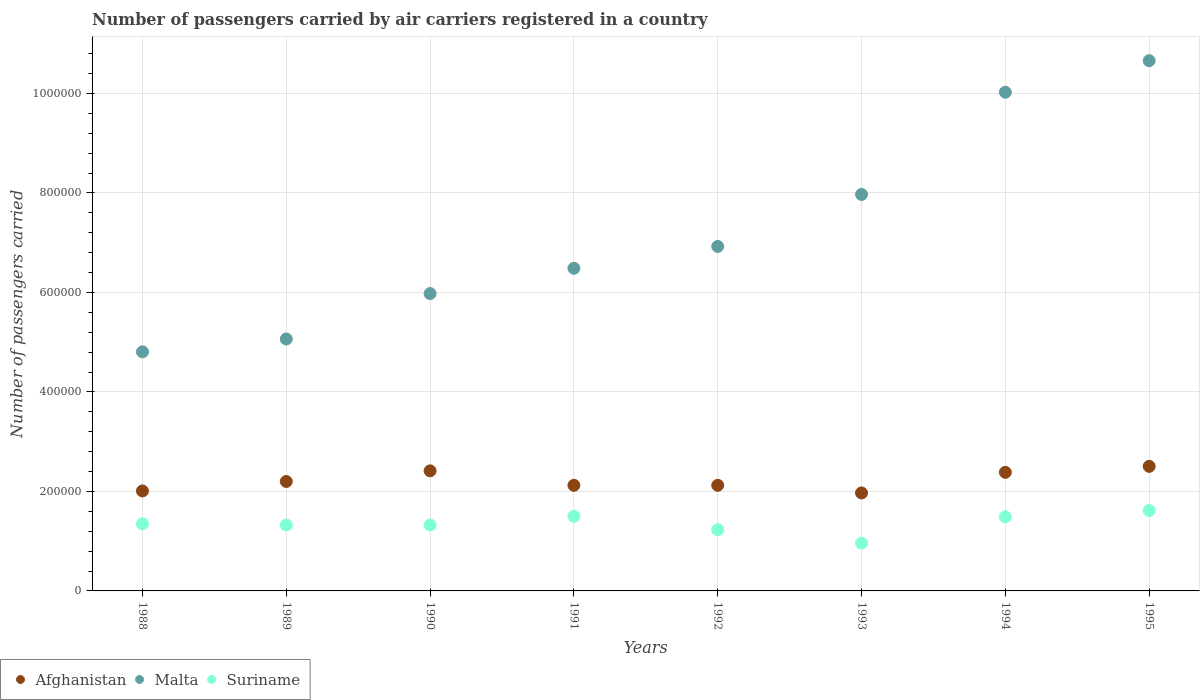Is the number of dotlines equal to the number of legend labels?
Offer a very short reply. Yes. What is the number of passengers carried by air carriers in Malta in 1991?
Ensure brevity in your answer.  6.49e+05. Across all years, what is the maximum number of passengers carried by air carriers in Afghanistan?
Give a very brief answer. 2.50e+05. Across all years, what is the minimum number of passengers carried by air carriers in Suriname?
Provide a succinct answer. 9.60e+04. In which year was the number of passengers carried by air carriers in Afghanistan minimum?
Keep it short and to the point. 1993. What is the total number of passengers carried by air carriers in Malta in the graph?
Your response must be concise. 5.79e+06. What is the difference between the number of passengers carried by air carriers in Afghanistan in 1988 and that in 1995?
Your answer should be very brief. -4.94e+04. What is the difference between the number of passengers carried by air carriers in Suriname in 1993 and the number of passengers carried by air carriers in Malta in 1992?
Keep it short and to the point. -5.96e+05. What is the average number of passengers carried by air carriers in Suriname per year?
Give a very brief answer. 1.35e+05. In the year 1988, what is the difference between the number of passengers carried by air carriers in Afghanistan and number of passengers carried by air carriers in Suriname?
Your answer should be compact. 6.60e+04. In how many years, is the number of passengers carried by air carriers in Malta greater than 240000?
Offer a terse response. 8. What is the ratio of the number of passengers carried by air carriers in Malta in 1993 to that in 1994?
Keep it short and to the point. 0.8. Is the number of passengers carried by air carriers in Afghanistan in 1990 less than that in 1993?
Make the answer very short. No. What is the difference between the highest and the second highest number of passengers carried by air carriers in Suriname?
Offer a terse response. 1.18e+04. What is the difference between the highest and the lowest number of passengers carried by air carriers in Malta?
Offer a very short reply. 5.85e+05. In how many years, is the number of passengers carried by air carriers in Suriname greater than the average number of passengers carried by air carriers in Suriname taken over all years?
Your answer should be compact. 4. Is it the case that in every year, the sum of the number of passengers carried by air carriers in Suriname and number of passengers carried by air carriers in Afghanistan  is greater than the number of passengers carried by air carriers in Malta?
Provide a succinct answer. No. Is the number of passengers carried by air carriers in Suriname strictly greater than the number of passengers carried by air carriers in Malta over the years?
Your response must be concise. No. Is the number of passengers carried by air carriers in Suriname strictly less than the number of passengers carried by air carriers in Malta over the years?
Provide a succinct answer. Yes. How many dotlines are there?
Provide a succinct answer. 3. Are the values on the major ticks of Y-axis written in scientific E-notation?
Give a very brief answer. No. Does the graph contain any zero values?
Your response must be concise. No. Where does the legend appear in the graph?
Ensure brevity in your answer.  Bottom left. How many legend labels are there?
Your answer should be compact. 3. How are the legend labels stacked?
Your answer should be compact. Horizontal. What is the title of the graph?
Provide a short and direct response. Number of passengers carried by air carriers registered in a country. Does "Grenada" appear as one of the legend labels in the graph?
Offer a terse response. No. What is the label or title of the X-axis?
Offer a very short reply. Years. What is the label or title of the Y-axis?
Ensure brevity in your answer.  Number of passengers carried. What is the Number of passengers carried of Afghanistan in 1988?
Your answer should be very brief. 2.01e+05. What is the Number of passengers carried in Malta in 1988?
Give a very brief answer. 4.81e+05. What is the Number of passengers carried in Suriname in 1988?
Your answer should be compact. 1.35e+05. What is the Number of passengers carried in Malta in 1989?
Your answer should be compact. 5.06e+05. What is the Number of passengers carried in Suriname in 1989?
Provide a succinct answer. 1.32e+05. What is the Number of passengers carried in Afghanistan in 1990?
Your answer should be compact. 2.41e+05. What is the Number of passengers carried in Malta in 1990?
Give a very brief answer. 5.98e+05. What is the Number of passengers carried in Suriname in 1990?
Offer a terse response. 1.32e+05. What is the Number of passengers carried in Afghanistan in 1991?
Your response must be concise. 2.12e+05. What is the Number of passengers carried in Malta in 1991?
Keep it short and to the point. 6.49e+05. What is the Number of passengers carried of Afghanistan in 1992?
Your response must be concise. 2.12e+05. What is the Number of passengers carried in Malta in 1992?
Offer a terse response. 6.92e+05. What is the Number of passengers carried in Suriname in 1992?
Provide a short and direct response. 1.23e+05. What is the Number of passengers carried in Afghanistan in 1993?
Offer a terse response. 1.97e+05. What is the Number of passengers carried of Malta in 1993?
Offer a terse response. 7.97e+05. What is the Number of passengers carried in Suriname in 1993?
Your answer should be compact. 9.60e+04. What is the Number of passengers carried in Afghanistan in 1994?
Give a very brief answer. 2.38e+05. What is the Number of passengers carried of Malta in 1994?
Make the answer very short. 1.00e+06. What is the Number of passengers carried of Suriname in 1994?
Make the answer very short. 1.49e+05. What is the Number of passengers carried of Afghanistan in 1995?
Your response must be concise. 2.50e+05. What is the Number of passengers carried in Malta in 1995?
Provide a succinct answer. 1.07e+06. What is the Number of passengers carried in Suriname in 1995?
Ensure brevity in your answer.  1.62e+05. Across all years, what is the maximum Number of passengers carried of Afghanistan?
Your answer should be very brief. 2.50e+05. Across all years, what is the maximum Number of passengers carried of Malta?
Provide a short and direct response. 1.07e+06. Across all years, what is the maximum Number of passengers carried of Suriname?
Make the answer very short. 1.62e+05. Across all years, what is the minimum Number of passengers carried of Afghanistan?
Give a very brief answer. 1.97e+05. Across all years, what is the minimum Number of passengers carried in Malta?
Ensure brevity in your answer.  4.81e+05. Across all years, what is the minimum Number of passengers carried in Suriname?
Ensure brevity in your answer.  9.60e+04. What is the total Number of passengers carried in Afghanistan in the graph?
Provide a succinct answer. 1.77e+06. What is the total Number of passengers carried in Malta in the graph?
Give a very brief answer. 5.79e+06. What is the total Number of passengers carried in Suriname in the graph?
Provide a succinct answer. 1.08e+06. What is the difference between the Number of passengers carried of Afghanistan in 1988 and that in 1989?
Offer a very short reply. -1.90e+04. What is the difference between the Number of passengers carried of Malta in 1988 and that in 1989?
Provide a succinct answer. -2.59e+04. What is the difference between the Number of passengers carried in Suriname in 1988 and that in 1989?
Your response must be concise. 2500. What is the difference between the Number of passengers carried of Afghanistan in 1988 and that in 1990?
Your answer should be very brief. -4.04e+04. What is the difference between the Number of passengers carried of Malta in 1988 and that in 1990?
Your response must be concise. -1.17e+05. What is the difference between the Number of passengers carried of Suriname in 1988 and that in 1990?
Your response must be concise. 2500. What is the difference between the Number of passengers carried in Afghanistan in 1988 and that in 1991?
Offer a terse response. -1.13e+04. What is the difference between the Number of passengers carried of Malta in 1988 and that in 1991?
Provide a succinct answer. -1.68e+05. What is the difference between the Number of passengers carried of Suriname in 1988 and that in 1991?
Your response must be concise. -1.50e+04. What is the difference between the Number of passengers carried of Afghanistan in 1988 and that in 1992?
Make the answer very short. -1.13e+04. What is the difference between the Number of passengers carried in Malta in 1988 and that in 1992?
Provide a short and direct response. -2.12e+05. What is the difference between the Number of passengers carried of Suriname in 1988 and that in 1992?
Make the answer very short. 1.20e+04. What is the difference between the Number of passengers carried in Afghanistan in 1988 and that in 1993?
Your answer should be very brief. 4000. What is the difference between the Number of passengers carried in Malta in 1988 and that in 1993?
Offer a very short reply. -3.16e+05. What is the difference between the Number of passengers carried in Suriname in 1988 and that in 1993?
Give a very brief answer. 3.90e+04. What is the difference between the Number of passengers carried of Afghanistan in 1988 and that in 1994?
Give a very brief answer. -3.74e+04. What is the difference between the Number of passengers carried in Malta in 1988 and that in 1994?
Provide a succinct answer. -5.22e+05. What is the difference between the Number of passengers carried in Suriname in 1988 and that in 1994?
Ensure brevity in your answer.  -1.39e+04. What is the difference between the Number of passengers carried in Afghanistan in 1988 and that in 1995?
Your response must be concise. -4.94e+04. What is the difference between the Number of passengers carried of Malta in 1988 and that in 1995?
Offer a terse response. -5.85e+05. What is the difference between the Number of passengers carried in Suriname in 1988 and that in 1995?
Provide a short and direct response. -2.68e+04. What is the difference between the Number of passengers carried of Afghanistan in 1989 and that in 1990?
Keep it short and to the point. -2.14e+04. What is the difference between the Number of passengers carried in Malta in 1989 and that in 1990?
Provide a succinct answer. -9.13e+04. What is the difference between the Number of passengers carried in Suriname in 1989 and that in 1990?
Keep it short and to the point. 0. What is the difference between the Number of passengers carried in Afghanistan in 1989 and that in 1991?
Your answer should be compact. 7700. What is the difference between the Number of passengers carried of Malta in 1989 and that in 1991?
Make the answer very short. -1.42e+05. What is the difference between the Number of passengers carried in Suriname in 1989 and that in 1991?
Provide a short and direct response. -1.75e+04. What is the difference between the Number of passengers carried in Afghanistan in 1989 and that in 1992?
Your response must be concise. 7700. What is the difference between the Number of passengers carried of Malta in 1989 and that in 1992?
Make the answer very short. -1.86e+05. What is the difference between the Number of passengers carried of Suriname in 1989 and that in 1992?
Offer a terse response. 9500. What is the difference between the Number of passengers carried of Afghanistan in 1989 and that in 1993?
Your response must be concise. 2.30e+04. What is the difference between the Number of passengers carried of Malta in 1989 and that in 1993?
Offer a terse response. -2.90e+05. What is the difference between the Number of passengers carried of Suriname in 1989 and that in 1993?
Provide a short and direct response. 3.65e+04. What is the difference between the Number of passengers carried of Afghanistan in 1989 and that in 1994?
Provide a short and direct response. -1.84e+04. What is the difference between the Number of passengers carried in Malta in 1989 and that in 1994?
Keep it short and to the point. -4.96e+05. What is the difference between the Number of passengers carried in Suriname in 1989 and that in 1994?
Provide a short and direct response. -1.64e+04. What is the difference between the Number of passengers carried of Afghanistan in 1989 and that in 1995?
Your answer should be compact. -3.04e+04. What is the difference between the Number of passengers carried of Malta in 1989 and that in 1995?
Ensure brevity in your answer.  -5.59e+05. What is the difference between the Number of passengers carried in Suriname in 1989 and that in 1995?
Offer a terse response. -2.93e+04. What is the difference between the Number of passengers carried of Afghanistan in 1990 and that in 1991?
Give a very brief answer. 2.91e+04. What is the difference between the Number of passengers carried of Malta in 1990 and that in 1991?
Your answer should be very brief. -5.08e+04. What is the difference between the Number of passengers carried of Suriname in 1990 and that in 1991?
Offer a very short reply. -1.75e+04. What is the difference between the Number of passengers carried in Afghanistan in 1990 and that in 1992?
Your answer should be very brief. 2.91e+04. What is the difference between the Number of passengers carried in Malta in 1990 and that in 1992?
Ensure brevity in your answer.  -9.47e+04. What is the difference between the Number of passengers carried of Suriname in 1990 and that in 1992?
Provide a succinct answer. 9500. What is the difference between the Number of passengers carried of Afghanistan in 1990 and that in 1993?
Your answer should be very brief. 4.44e+04. What is the difference between the Number of passengers carried in Malta in 1990 and that in 1993?
Offer a terse response. -1.99e+05. What is the difference between the Number of passengers carried in Suriname in 1990 and that in 1993?
Your answer should be compact. 3.65e+04. What is the difference between the Number of passengers carried of Afghanistan in 1990 and that in 1994?
Provide a succinct answer. 3000. What is the difference between the Number of passengers carried of Malta in 1990 and that in 1994?
Give a very brief answer. -4.05e+05. What is the difference between the Number of passengers carried in Suriname in 1990 and that in 1994?
Ensure brevity in your answer.  -1.64e+04. What is the difference between the Number of passengers carried in Afghanistan in 1990 and that in 1995?
Provide a succinct answer. -9000. What is the difference between the Number of passengers carried in Malta in 1990 and that in 1995?
Offer a very short reply. -4.68e+05. What is the difference between the Number of passengers carried of Suriname in 1990 and that in 1995?
Provide a succinct answer. -2.93e+04. What is the difference between the Number of passengers carried of Afghanistan in 1991 and that in 1992?
Ensure brevity in your answer.  0. What is the difference between the Number of passengers carried in Malta in 1991 and that in 1992?
Provide a short and direct response. -4.39e+04. What is the difference between the Number of passengers carried in Suriname in 1991 and that in 1992?
Provide a succinct answer. 2.70e+04. What is the difference between the Number of passengers carried of Afghanistan in 1991 and that in 1993?
Offer a terse response. 1.53e+04. What is the difference between the Number of passengers carried of Malta in 1991 and that in 1993?
Give a very brief answer. -1.48e+05. What is the difference between the Number of passengers carried in Suriname in 1991 and that in 1993?
Your answer should be very brief. 5.40e+04. What is the difference between the Number of passengers carried in Afghanistan in 1991 and that in 1994?
Provide a succinct answer. -2.61e+04. What is the difference between the Number of passengers carried of Malta in 1991 and that in 1994?
Keep it short and to the point. -3.54e+05. What is the difference between the Number of passengers carried of Suriname in 1991 and that in 1994?
Your answer should be very brief. 1100. What is the difference between the Number of passengers carried of Afghanistan in 1991 and that in 1995?
Keep it short and to the point. -3.81e+04. What is the difference between the Number of passengers carried in Malta in 1991 and that in 1995?
Provide a short and direct response. -4.17e+05. What is the difference between the Number of passengers carried of Suriname in 1991 and that in 1995?
Keep it short and to the point. -1.18e+04. What is the difference between the Number of passengers carried of Afghanistan in 1992 and that in 1993?
Keep it short and to the point. 1.53e+04. What is the difference between the Number of passengers carried of Malta in 1992 and that in 1993?
Offer a very short reply. -1.04e+05. What is the difference between the Number of passengers carried of Suriname in 1992 and that in 1993?
Your answer should be very brief. 2.70e+04. What is the difference between the Number of passengers carried of Afghanistan in 1992 and that in 1994?
Your response must be concise. -2.61e+04. What is the difference between the Number of passengers carried of Malta in 1992 and that in 1994?
Make the answer very short. -3.10e+05. What is the difference between the Number of passengers carried of Suriname in 1992 and that in 1994?
Keep it short and to the point. -2.59e+04. What is the difference between the Number of passengers carried of Afghanistan in 1992 and that in 1995?
Provide a succinct answer. -3.81e+04. What is the difference between the Number of passengers carried in Malta in 1992 and that in 1995?
Provide a short and direct response. -3.73e+05. What is the difference between the Number of passengers carried of Suriname in 1992 and that in 1995?
Make the answer very short. -3.88e+04. What is the difference between the Number of passengers carried of Afghanistan in 1993 and that in 1994?
Your answer should be compact. -4.14e+04. What is the difference between the Number of passengers carried of Malta in 1993 and that in 1994?
Your response must be concise. -2.06e+05. What is the difference between the Number of passengers carried in Suriname in 1993 and that in 1994?
Offer a terse response. -5.29e+04. What is the difference between the Number of passengers carried of Afghanistan in 1993 and that in 1995?
Provide a short and direct response. -5.34e+04. What is the difference between the Number of passengers carried in Malta in 1993 and that in 1995?
Your response must be concise. -2.69e+05. What is the difference between the Number of passengers carried of Suriname in 1993 and that in 1995?
Give a very brief answer. -6.58e+04. What is the difference between the Number of passengers carried in Afghanistan in 1994 and that in 1995?
Offer a very short reply. -1.20e+04. What is the difference between the Number of passengers carried of Malta in 1994 and that in 1995?
Provide a short and direct response. -6.34e+04. What is the difference between the Number of passengers carried of Suriname in 1994 and that in 1995?
Keep it short and to the point. -1.29e+04. What is the difference between the Number of passengers carried of Afghanistan in 1988 and the Number of passengers carried of Malta in 1989?
Give a very brief answer. -3.06e+05. What is the difference between the Number of passengers carried in Afghanistan in 1988 and the Number of passengers carried in Suriname in 1989?
Give a very brief answer. 6.85e+04. What is the difference between the Number of passengers carried in Malta in 1988 and the Number of passengers carried in Suriname in 1989?
Offer a very short reply. 3.48e+05. What is the difference between the Number of passengers carried of Afghanistan in 1988 and the Number of passengers carried of Malta in 1990?
Your answer should be very brief. -3.97e+05. What is the difference between the Number of passengers carried in Afghanistan in 1988 and the Number of passengers carried in Suriname in 1990?
Give a very brief answer. 6.85e+04. What is the difference between the Number of passengers carried of Malta in 1988 and the Number of passengers carried of Suriname in 1990?
Ensure brevity in your answer.  3.48e+05. What is the difference between the Number of passengers carried in Afghanistan in 1988 and the Number of passengers carried in Malta in 1991?
Make the answer very short. -4.48e+05. What is the difference between the Number of passengers carried in Afghanistan in 1988 and the Number of passengers carried in Suriname in 1991?
Offer a very short reply. 5.10e+04. What is the difference between the Number of passengers carried of Malta in 1988 and the Number of passengers carried of Suriname in 1991?
Provide a succinct answer. 3.31e+05. What is the difference between the Number of passengers carried in Afghanistan in 1988 and the Number of passengers carried in Malta in 1992?
Keep it short and to the point. -4.92e+05. What is the difference between the Number of passengers carried in Afghanistan in 1988 and the Number of passengers carried in Suriname in 1992?
Your answer should be compact. 7.80e+04. What is the difference between the Number of passengers carried in Malta in 1988 and the Number of passengers carried in Suriname in 1992?
Your answer should be compact. 3.58e+05. What is the difference between the Number of passengers carried in Afghanistan in 1988 and the Number of passengers carried in Malta in 1993?
Keep it short and to the point. -5.96e+05. What is the difference between the Number of passengers carried in Afghanistan in 1988 and the Number of passengers carried in Suriname in 1993?
Keep it short and to the point. 1.05e+05. What is the difference between the Number of passengers carried in Malta in 1988 and the Number of passengers carried in Suriname in 1993?
Provide a succinct answer. 3.85e+05. What is the difference between the Number of passengers carried of Afghanistan in 1988 and the Number of passengers carried of Malta in 1994?
Offer a terse response. -8.02e+05. What is the difference between the Number of passengers carried of Afghanistan in 1988 and the Number of passengers carried of Suriname in 1994?
Your answer should be very brief. 5.21e+04. What is the difference between the Number of passengers carried of Malta in 1988 and the Number of passengers carried of Suriname in 1994?
Offer a terse response. 3.32e+05. What is the difference between the Number of passengers carried of Afghanistan in 1988 and the Number of passengers carried of Malta in 1995?
Ensure brevity in your answer.  -8.65e+05. What is the difference between the Number of passengers carried in Afghanistan in 1988 and the Number of passengers carried in Suriname in 1995?
Keep it short and to the point. 3.92e+04. What is the difference between the Number of passengers carried in Malta in 1988 and the Number of passengers carried in Suriname in 1995?
Provide a short and direct response. 3.19e+05. What is the difference between the Number of passengers carried of Afghanistan in 1989 and the Number of passengers carried of Malta in 1990?
Provide a succinct answer. -3.78e+05. What is the difference between the Number of passengers carried in Afghanistan in 1989 and the Number of passengers carried in Suriname in 1990?
Ensure brevity in your answer.  8.75e+04. What is the difference between the Number of passengers carried of Malta in 1989 and the Number of passengers carried of Suriname in 1990?
Offer a terse response. 3.74e+05. What is the difference between the Number of passengers carried in Afghanistan in 1989 and the Number of passengers carried in Malta in 1991?
Provide a succinct answer. -4.29e+05. What is the difference between the Number of passengers carried of Afghanistan in 1989 and the Number of passengers carried of Suriname in 1991?
Your response must be concise. 7.00e+04. What is the difference between the Number of passengers carried of Malta in 1989 and the Number of passengers carried of Suriname in 1991?
Your answer should be very brief. 3.56e+05. What is the difference between the Number of passengers carried in Afghanistan in 1989 and the Number of passengers carried in Malta in 1992?
Give a very brief answer. -4.72e+05. What is the difference between the Number of passengers carried of Afghanistan in 1989 and the Number of passengers carried of Suriname in 1992?
Offer a terse response. 9.70e+04. What is the difference between the Number of passengers carried of Malta in 1989 and the Number of passengers carried of Suriname in 1992?
Keep it short and to the point. 3.84e+05. What is the difference between the Number of passengers carried of Afghanistan in 1989 and the Number of passengers carried of Malta in 1993?
Provide a short and direct response. -5.77e+05. What is the difference between the Number of passengers carried of Afghanistan in 1989 and the Number of passengers carried of Suriname in 1993?
Make the answer very short. 1.24e+05. What is the difference between the Number of passengers carried in Malta in 1989 and the Number of passengers carried in Suriname in 1993?
Offer a very short reply. 4.10e+05. What is the difference between the Number of passengers carried in Afghanistan in 1989 and the Number of passengers carried in Malta in 1994?
Ensure brevity in your answer.  -7.82e+05. What is the difference between the Number of passengers carried of Afghanistan in 1989 and the Number of passengers carried of Suriname in 1994?
Ensure brevity in your answer.  7.11e+04. What is the difference between the Number of passengers carried in Malta in 1989 and the Number of passengers carried in Suriname in 1994?
Offer a very short reply. 3.58e+05. What is the difference between the Number of passengers carried of Afghanistan in 1989 and the Number of passengers carried of Malta in 1995?
Your answer should be very brief. -8.46e+05. What is the difference between the Number of passengers carried of Afghanistan in 1989 and the Number of passengers carried of Suriname in 1995?
Make the answer very short. 5.82e+04. What is the difference between the Number of passengers carried in Malta in 1989 and the Number of passengers carried in Suriname in 1995?
Your response must be concise. 3.45e+05. What is the difference between the Number of passengers carried of Afghanistan in 1990 and the Number of passengers carried of Malta in 1991?
Your answer should be very brief. -4.07e+05. What is the difference between the Number of passengers carried of Afghanistan in 1990 and the Number of passengers carried of Suriname in 1991?
Give a very brief answer. 9.14e+04. What is the difference between the Number of passengers carried of Malta in 1990 and the Number of passengers carried of Suriname in 1991?
Your answer should be compact. 4.48e+05. What is the difference between the Number of passengers carried in Afghanistan in 1990 and the Number of passengers carried in Malta in 1992?
Offer a very short reply. -4.51e+05. What is the difference between the Number of passengers carried in Afghanistan in 1990 and the Number of passengers carried in Suriname in 1992?
Keep it short and to the point. 1.18e+05. What is the difference between the Number of passengers carried in Malta in 1990 and the Number of passengers carried in Suriname in 1992?
Make the answer very short. 4.75e+05. What is the difference between the Number of passengers carried in Afghanistan in 1990 and the Number of passengers carried in Malta in 1993?
Ensure brevity in your answer.  -5.56e+05. What is the difference between the Number of passengers carried of Afghanistan in 1990 and the Number of passengers carried of Suriname in 1993?
Make the answer very short. 1.45e+05. What is the difference between the Number of passengers carried of Malta in 1990 and the Number of passengers carried of Suriname in 1993?
Your answer should be compact. 5.02e+05. What is the difference between the Number of passengers carried in Afghanistan in 1990 and the Number of passengers carried in Malta in 1994?
Provide a succinct answer. -7.61e+05. What is the difference between the Number of passengers carried in Afghanistan in 1990 and the Number of passengers carried in Suriname in 1994?
Keep it short and to the point. 9.25e+04. What is the difference between the Number of passengers carried of Malta in 1990 and the Number of passengers carried of Suriname in 1994?
Keep it short and to the point. 4.49e+05. What is the difference between the Number of passengers carried in Afghanistan in 1990 and the Number of passengers carried in Malta in 1995?
Offer a terse response. -8.24e+05. What is the difference between the Number of passengers carried in Afghanistan in 1990 and the Number of passengers carried in Suriname in 1995?
Offer a terse response. 7.96e+04. What is the difference between the Number of passengers carried in Malta in 1990 and the Number of passengers carried in Suriname in 1995?
Ensure brevity in your answer.  4.36e+05. What is the difference between the Number of passengers carried of Afghanistan in 1991 and the Number of passengers carried of Malta in 1992?
Ensure brevity in your answer.  -4.80e+05. What is the difference between the Number of passengers carried in Afghanistan in 1991 and the Number of passengers carried in Suriname in 1992?
Make the answer very short. 8.93e+04. What is the difference between the Number of passengers carried of Malta in 1991 and the Number of passengers carried of Suriname in 1992?
Your answer should be very brief. 5.26e+05. What is the difference between the Number of passengers carried of Afghanistan in 1991 and the Number of passengers carried of Malta in 1993?
Provide a short and direct response. -5.85e+05. What is the difference between the Number of passengers carried in Afghanistan in 1991 and the Number of passengers carried in Suriname in 1993?
Ensure brevity in your answer.  1.16e+05. What is the difference between the Number of passengers carried in Malta in 1991 and the Number of passengers carried in Suriname in 1993?
Your answer should be compact. 5.53e+05. What is the difference between the Number of passengers carried of Afghanistan in 1991 and the Number of passengers carried of Malta in 1994?
Provide a succinct answer. -7.90e+05. What is the difference between the Number of passengers carried of Afghanistan in 1991 and the Number of passengers carried of Suriname in 1994?
Give a very brief answer. 6.34e+04. What is the difference between the Number of passengers carried of Malta in 1991 and the Number of passengers carried of Suriname in 1994?
Your answer should be very brief. 5.00e+05. What is the difference between the Number of passengers carried in Afghanistan in 1991 and the Number of passengers carried in Malta in 1995?
Offer a terse response. -8.54e+05. What is the difference between the Number of passengers carried of Afghanistan in 1991 and the Number of passengers carried of Suriname in 1995?
Ensure brevity in your answer.  5.05e+04. What is the difference between the Number of passengers carried in Malta in 1991 and the Number of passengers carried in Suriname in 1995?
Give a very brief answer. 4.87e+05. What is the difference between the Number of passengers carried in Afghanistan in 1992 and the Number of passengers carried in Malta in 1993?
Your answer should be very brief. -5.85e+05. What is the difference between the Number of passengers carried in Afghanistan in 1992 and the Number of passengers carried in Suriname in 1993?
Make the answer very short. 1.16e+05. What is the difference between the Number of passengers carried in Malta in 1992 and the Number of passengers carried in Suriname in 1993?
Make the answer very short. 5.96e+05. What is the difference between the Number of passengers carried of Afghanistan in 1992 and the Number of passengers carried of Malta in 1994?
Ensure brevity in your answer.  -7.90e+05. What is the difference between the Number of passengers carried in Afghanistan in 1992 and the Number of passengers carried in Suriname in 1994?
Provide a succinct answer. 6.34e+04. What is the difference between the Number of passengers carried of Malta in 1992 and the Number of passengers carried of Suriname in 1994?
Make the answer very short. 5.44e+05. What is the difference between the Number of passengers carried of Afghanistan in 1992 and the Number of passengers carried of Malta in 1995?
Your answer should be compact. -8.54e+05. What is the difference between the Number of passengers carried in Afghanistan in 1992 and the Number of passengers carried in Suriname in 1995?
Your response must be concise. 5.05e+04. What is the difference between the Number of passengers carried in Malta in 1992 and the Number of passengers carried in Suriname in 1995?
Provide a short and direct response. 5.31e+05. What is the difference between the Number of passengers carried in Afghanistan in 1993 and the Number of passengers carried in Malta in 1994?
Ensure brevity in your answer.  -8.06e+05. What is the difference between the Number of passengers carried in Afghanistan in 1993 and the Number of passengers carried in Suriname in 1994?
Ensure brevity in your answer.  4.81e+04. What is the difference between the Number of passengers carried in Malta in 1993 and the Number of passengers carried in Suriname in 1994?
Your response must be concise. 6.48e+05. What is the difference between the Number of passengers carried of Afghanistan in 1993 and the Number of passengers carried of Malta in 1995?
Give a very brief answer. -8.69e+05. What is the difference between the Number of passengers carried in Afghanistan in 1993 and the Number of passengers carried in Suriname in 1995?
Provide a short and direct response. 3.52e+04. What is the difference between the Number of passengers carried of Malta in 1993 and the Number of passengers carried of Suriname in 1995?
Provide a short and direct response. 6.35e+05. What is the difference between the Number of passengers carried of Afghanistan in 1994 and the Number of passengers carried of Malta in 1995?
Ensure brevity in your answer.  -8.28e+05. What is the difference between the Number of passengers carried of Afghanistan in 1994 and the Number of passengers carried of Suriname in 1995?
Your answer should be very brief. 7.66e+04. What is the difference between the Number of passengers carried of Malta in 1994 and the Number of passengers carried of Suriname in 1995?
Your response must be concise. 8.41e+05. What is the average Number of passengers carried of Afghanistan per year?
Provide a short and direct response. 2.22e+05. What is the average Number of passengers carried of Malta per year?
Your response must be concise. 7.24e+05. What is the average Number of passengers carried in Suriname per year?
Give a very brief answer. 1.35e+05. In the year 1988, what is the difference between the Number of passengers carried in Afghanistan and Number of passengers carried in Malta?
Give a very brief answer. -2.80e+05. In the year 1988, what is the difference between the Number of passengers carried of Afghanistan and Number of passengers carried of Suriname?
Keep it short and to the point. 6.60e+04. In the year 1988, what is the difference between the Number of passengers carried in Malta and Number of passengers carried in Suriname?
Offer a very short reply. 3.46e+05. In the year 1989, what is the difference between the Number of passengers carried in Afghanistan and Number of passengers carried in Malta?
Make the answer very short. -2.86e+05. In the year 1989, what is the difference between the Number of passengers carried of Afghanistan and Number of passengers carried of Suriname?
Your response must be concise. 8.75e+04. In the year 1989, what is the difference between the Number of passengers carried of Malta and Number of passengers carried of Suriname?
Provide a short and direct response. 3.74e+05. In the year 1990, what is the difference between the Number of passengers carried in Afghanistan and Number of passengers carried in Malta?
Your answer should be very brief. -3.56e+05. In the year 1990, what is the difference between the Number of passengers carried of Afghanistan and Number of passengers carried of Suriname?
Your answer should be very brief. 1.09e+05. In the year 1990, what is the difference between the Number of passengers carried of Malta and Number of passengers carried of Suriname?
Your response must be concise. 4.65e+05. In the year 1991, what is the difference between the Number of passengers carried in Afghanistan and Number of passengers carried in Malta?
Your response must be concise. -4.36e+05. In the year 1991, what is the difference between the Number of passengers carried in Afghanistan and Number of passengers carried in Suriname?
Ensure brevity in your answer.  6.23e+04. In the year 1991, what is the difference between the Number of passengers carried of Malta and Number of passengers carried of Suriname?
Give a very brief answer. 4.99e+05. In the year 1992, what is the difference between the Number of passengers carried in Afghanistan and Number of passengers carried in Malta?
Provide a succinct answer. -4.80e+05. In the year 1992, what is the difference between the Number of passengers carried in Afghanistan and Number of passengers carried in Suriname?
Give a very brief answer. 8.93e+04. In the year 1992, what is the difference between the Number of passengers carried of Malta and Number of passengers carried of Suriname?
Make the answer very short. 5.70e+05. In the year 1993, what is the difference between the Number of passengers carried of Afghanistan and Number of passengers carried of Malta?
Offer a very short reply. -6.00e+05. In the year 1993, what is the difference between the Number of passengers carried in Afghanistan and Number of passengers carried in Suriname?
Provide a short and direct response. 1.01e+05. In the year 1993, what is the difference between the Number of passengers carried of Malta and Number of passengers carried of Suriname?
Provide a succinct answer. 7.01e+05. In the year 1994, what is the difference between the Number of passengers carried in Afghanistan and Number of passengers carried in Malta?
Keep it short and to the point. -7.64e+05. In the year 1994, what is the difference between the Number of passengers carried in Afghanistan and Number of passengers carried in Suriname?
Provide a succinct answer. 8.95e+04. In the year 1994, what is the difference between the Number of passengers carried of Malta and Number of passengers carried of Suriname?
Your answer should be compact. 8.54e+05. In the year 1995, what is the difference between the Number of passengers carried in Afghanistan and Number of passengers carried in Malta?
Your answer should be compact. -8.16e+05. In the year 1995, what is the difference between the Number of passengers carried of Afghanistan and Number of passengers carried of Suriname?
Your response must be concise. 8.86e+04. In the year 1995, what is the difference between the Number of passengers carried in Malta and Number of passengers carried in Suriname?
Your answer should be very brief. 9.04e+05. What is the ratio of the Number of passengers carried in Afghanistan in 1988 to that in 1989?
Provide a short and direct response. 0.91. What is the ratio of the Number of passengers carried in Malta in 1988 to that in 1989?
Provide a short and direct response. 0.95. What is the ratio of the Number of passengers carried in Suriname in 1988 to that in 1989?
Offer a very short reply. 1.02. What is the ratio of the Number of passengers carried in Afghanistan in 1988 to that in 1990?
Make the answer very short. 0.83. What is the ratio of the Number of passengers carried in Malta in 1988 to that in 1990?
Your answer should be compact. 0.8. What is the ratio of the Number of passengers carried of Suriname in 1988 to that in 1990?
Ensure brevity in your answer.  1.02. What is the ratio of the Number of passengers carried in Afghanistan in 1988 to that in 1991?
Provide a short and direct response. 0.95. What is the ratio of the Number of passengers carried in Malta in 1988 to that in 1991?
Offer a terse response. 0.74. What is the ratio of the Number of passengers carried in Afghanistan in 1988 to that in 1992?
Keep it short and to the point. 0.95. What is the ratio of the Number of passengers carried of Malta in 1988 to that in 1992?
Your answer should be very brief. 0.69. What is the ratio of the Number of passengers carried in Suriname in 1988 to that in 1992?
Your answer should be very brief. 1.1. What is the ratio of the Number of passengers carried in Afghanistan in 1988 to that in 1993?
Ensure brevity in your answer.  1.02. What is the ratio of the Number of passengers carried of Malta in 1988 to that in 1993?
Make the answer very short. 0.6. What is the ratio of the Number of passengers carried in Suriname in 1988 to that in 1993?
Offer a very short reply. 1.41. What is the ratio of the Number of passengers carried in Afghanistan in 1988 to that in 1994?
Keep it short and to the point. 0.84. What is the ratio of the Number of passengers carried of Malta in 1988 to that in 1994?
Offer a terse response. 0.48. What is the ratio of the Number of passengers carried in Suriname in 1988 to that in 1994?
Provide a succinct answer. 0.91. What is the ratio of the Number of passengers carried of Afghanistan in 1988 to that in 1995?
Offer a terse response. 0.8. What is the ratio of the Number of passengers carried in Malta in 1988 to that in 1995?
Keep it short and to the point. 0.45. What is the ratio of the Number of passengers carried of Suriname in 1988 to that in 1995?
Offer a terse response. 0.83. What is the ratio of the Number of passengers carried in Afghanistan in 1989 to that in 1990?
Offer a very short reply. 0.91. What is the ratio of the Number of passengers carried in Malta in 1989 to that in 1990?
Ensure brevity in your answer.  0.85. What is the ratio of the Number of passengers carried in Suriname in 1989 to that in 1990?
Offer a terse response. 1. What is the ratio of the Number of passengers carried of Afghanistan in 1989 to that in 1991?
Ensure brevity in your answer.  1.04. What is the ratio of the Number of passengers carried of Malta in 1989 to that in 1991?
Your answer should be compact. 0.78. What is the ratio of the Number of passengers carried of Suriname in 1989 to that in 1991?
Offer a terse response. 0.88. What is the ratio of the Number of passengers carried of Afghanistan in 1989 to that in 1992?
Provide a short and direct response. 1.04. What is the ratio of the Number of passengers carried in Malta in 1989 to that in 1992?
Provide a short and direct response. 0.73. What is the ratio of the Number of passengers carried of Suriname in 1989 to that in 1992?
Make the answer very short. 1.08. What is the ratio of the Number of passengers carried in Afghanistan in 1989 to that in 1993?
Your answer should be very brief. 1.12. What is the ratio of the Number of passengers carried in Malta in 1989 to that in 1993?
Your answer should be very brief. 0.64. What is the ratio of the Number of passengers carried of Suriname in 1989 to that in 1993?
Provide a succinct answer. 1.38. What is the ratio of the Number of passengers carried of Afghanistan in 1989 to that in 1994?
Your answer should be very brief. 0.92. What is the ratio of the Number of passengers carried in Malta in 1989 to that in 1994?
Offer a terse response. 0.51. What is the ratio of the Number of passengers carried in Suriname in 1989 to that in 1994?
Keep it short and to the point. 0.89. What is the ratio of the Number of passengers carried of Afghanistan in 1989 to that in 1995?
Your answer should be very brief. 0.88. What is the ratio of the Number of passengers carried of Malta in 1989 to that in 1995?
Make the answer very short. 0.48. What is the ratio of the Number of passengers carried of Suriname in 1989 to that in 1995?
Offer a terse response. 0.82. What is the ratio of the Number of passengers carried of Afghanistan in 1990 to that in 1991?
Offer a terse response. 1.14. What is the ratio of the Number of passengers carried of Malta in 1990 to that in 1991?
Keep it short and to the point. 0.92. What is the ratio of the Number of passengers carried of Suriname in 1990 to that in 1991?
Give a very brief answer. 0.88. What is the ratio of the Number of passengers carried of Afghanistan in 1990 to that in 1992?
Give a very brief answer. 1.14. What is the ratio of the Number of passengers carried in Malta in 1990 to that in 1992?
Provide a short and direct response. 0.86. What is the ratio of the Number of passengers carried in Suriname in 1990 to that in 1992?
Keep it short and to the point. 1.08. What is the ratio of the Number of passengers carried of Afghanistan in 1990 to that in 1993?
Make the answer very short. 1.23. What is the ratio of the Number of passengers carried of Malta in 1990 to that in 1993?
Your answer should be compact. 0.75. What is the ratio of the Number of passengers carried in Suriname in 1990 to that in 1993?
Offer a terse response. 1.38. What is the ratio of the Number of passengers carried in Afghanistan in 1990 to that in 1994?
Your answer should be compact. 1.01. What is the ratio of the Number of passengers carried in Malta in 1990 to that in 1994?
Make the answer very short. 0.6. What is the ratio of the Number of passengers carried of Suriname in 1990 to that in 1994?
Your answer should be very brief. 0.89. What is the ratio of the Number of passengers carried in Afghanistan in 1990 to that in 1995?
Your response must be concise. 0.96. What is the ratio of the Number of passengers carried of Malta in 1990 to that in 1995?
Keep it short and to the point. 0.56. What is the ratio of the Number of passengers carried in Suriname in 1990 to that in 1995?
Your answer should be very brief. 0.82. What is the ratio of the Number of passengers carried of Malta in 1991 to that in 1992?
Provide a short and direct response. 0.94. What is the ratio of the Number of passengers carried in Suriname in 1991 to that in 1992?
Keep it short and to the point. 1.22. What is the ratio of the Number of passengers carried of Afghanistan in 1991 to that in 1993?
Provide a short and direct response. 1.08. What is the ratio of the Number of passengers carried of Malta in 1991 to that in 1993?
Your answer should be compact. 0.81. What is the ratio of the Number of passengers carried in Suriname in 1991 to that in 1993?
Your answer should be compact. 1.56. What is the ratio of the Number of passengers carried of Afghanistan in 1991 to that in 1994?
Provide a succinct answer. 0.89. What is the ratio of the Number of passengers carried of Malta in 1991 to that in 1994?
Keep it short and to the point. 0.65. What is the ratio of the Number of passengers carried in Suriname in 1991 to that in 1994?
Your answer should be compact. 1.01. What is the ratio of the Number of passengers carried of Afghanistan in 1991 to that in 1995?
Your answer should be compact. 0.85. What is the ratio of the Number of passengers carried of Malta in 1991 to that in 1995?
Keep it short and to the point. 0.61. What is the ratio of the Number of passengers carried of Suriname in 1991 to that in 1995?
Offer a very short reply. 0.93. What is the ratio of the Number of passengers carried in Afghanistan in 1992 to that in 1993?
Ensure brevity in your answer.  1.08. What is the ratio of the Number of passengers carried of Malta in 1992 to that in 1993?
Keep it short and to the point. 0.87. What is the ratio of the Number of passengers carried of Suriname in 1992 to that in 1993?
Keep it short and to the point. 1.28. What is the ratio of the Number of passengers carried of Afghanistan in 1992 to that in 1994?
Keep it short and to the point. 0.89. What is the ratio of the Number of passengers carried of Malta in 1992 to that in 1994?
Give a very brief answer. 0.69. What is the ratio of the Number of passengers carried of Suriname in 1992 to that in 1994?
Make the answer very short. 0.83. What is the ratio of the Number of passengers carried in Afghanistan in 1992 to that in 1995?
Your response must be concise. 0.85. What is the ratio of the Number of passengers carried in Malta in 1992 to that in 1995?
Your answer should be very brief. 0.65. What is the ratio of the Number of passengers carried of Suriname in 1992 to that in 1995?
Give a very brief answer. 0.76. What is the ratio of the Number of passengers carried in Afghanistan in 1993 to that in 1994?
Your response must be concise. 0.83. What is the ratio of the Number of passengers carried of Malta in 1993 to that in 1994?
Ensure brevity in your answer.  0.8. What is the ratio of the Number of passengers carried of Suriname in 1993 to that in 1994?
Your answer should be very brief. 0.64. What is the ratio of the Number of passengers carried in Afghanistan in 1993 to that in 1995?
Make the answer very short. 0.79. What is the ratio of the Number of passengers carried in Malta in 1993 to that in 1995?
Offer a terse response. 0.75. What is the ratio of the Number of passengers carried in Suriname in 1993 to that in 1995?
Provide a short and direct response. 0.59. What is the ratio of the Number of passengers carried of Afghanistan in 1994 to that in 1995?
Your answer should be compact. 0.95. What is the ratio of the Number of passengers carried in Malta in 1994 to that in 1995?
Keep it short and to the point. 0.94. What is the ratio of the Number of passengers carried of Suriname in 1994 to that in 1995?
Your answer should be very brief. 0.92. What is the difference between the highest and the second highest Number of passengers carried of Afghanistan?
Your answer should be compact. 9000. What is the difference between the highest and the second highest Number of passengers carried of Malta?
Offer a very short reply. 6.34e+04. What is the difference between the highest and the second highest Number of passengers carried in Suriname?
Make the answer very short. 1.18e+04. What is the difference between the highest and the lowest Number of passengers carried of Afghanistan?
Provide a succinct answer. 5.34e+04. What is the difference between the highest and the lowest Number of passengers carried in Malta?
Your answer should be compact. 5.85e+05. What is the difference between the highest and the lowest Number of passengers carried of Suriname?
Keep it short and to the point. 6.58e+04. 